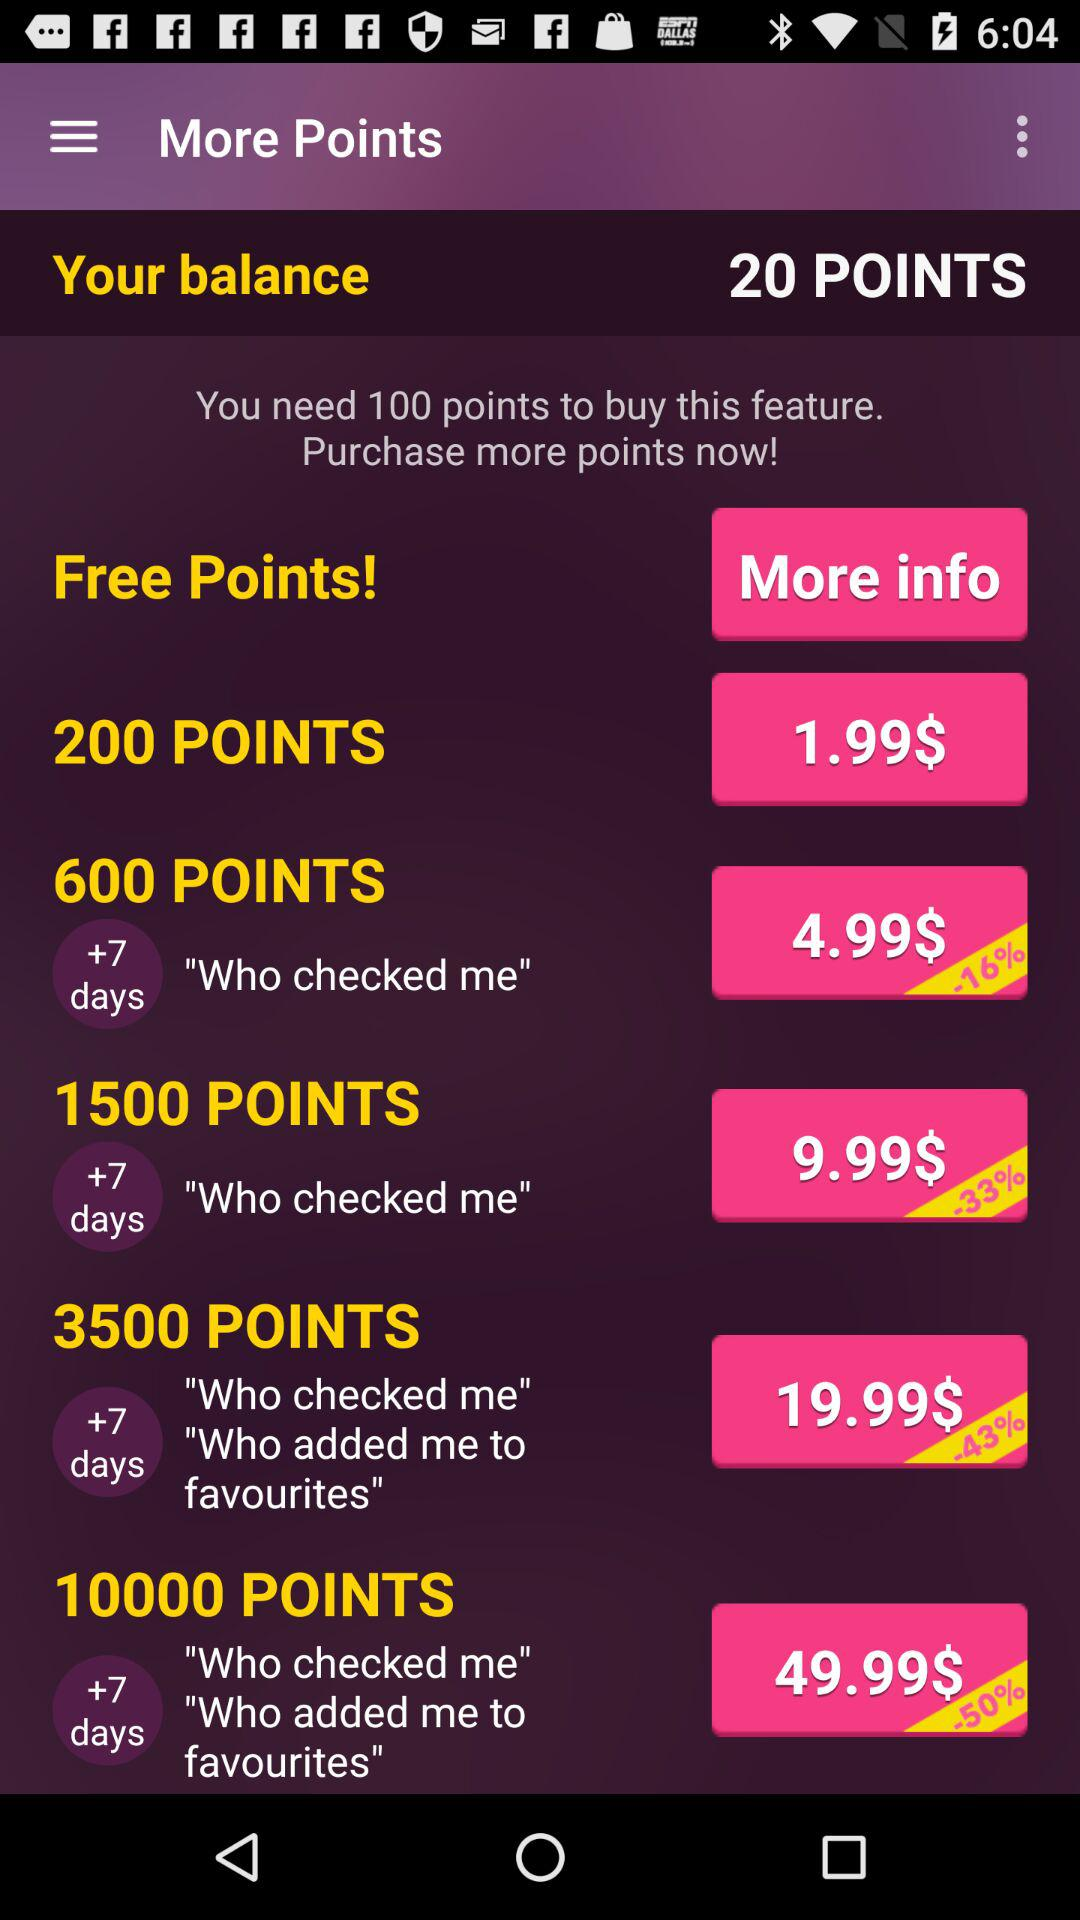How many points do I need to buy this feature? You need 100 points to buy this feature. 